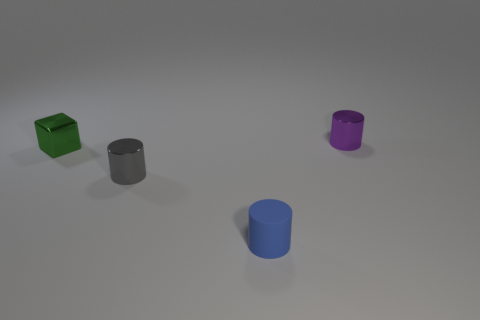Subtract all blue cylinders. Subtract all yellow balls. How many cylinders are left? 2 Add 4 small purple cylinders. How many objects exist? 8 Subtract all blocks. How many objects are left? 3 Add 4 blue cubes. How many blue cubes exist? 4 Subtract 1 purple cylinders. How many objects are left? 3 Subtract all green shiny things. Subtract all small purple things. How many objects are left? 2 Add 3 small rubber cylinders. How many small rubber cylinders are left? 4 